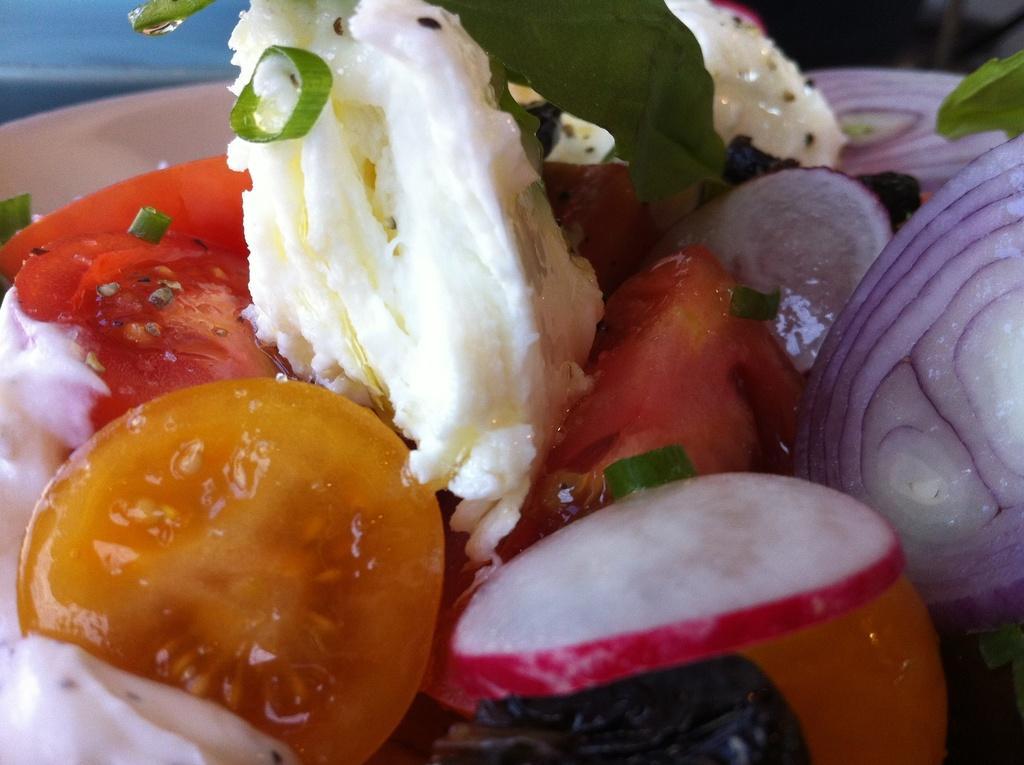Describe this image in one or two sentences. In this image I can see a white color plate which consists of some food items in it. 